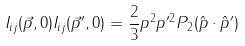Convert formula to latex. <formula><loc_0><loc_0><loc_500><loc_500>I _ { i j } ( \vec { p } , 0 ) I _ { i j } ( \vec { p } ^ { \prime } , 0 ) = \frac { 2 } { 3 } p ^ { 2 } p ^ { \prime 2 } P _ { 2 } ( \hat { p } \cdot \hat { p } ^ { \prime } )</formula> 